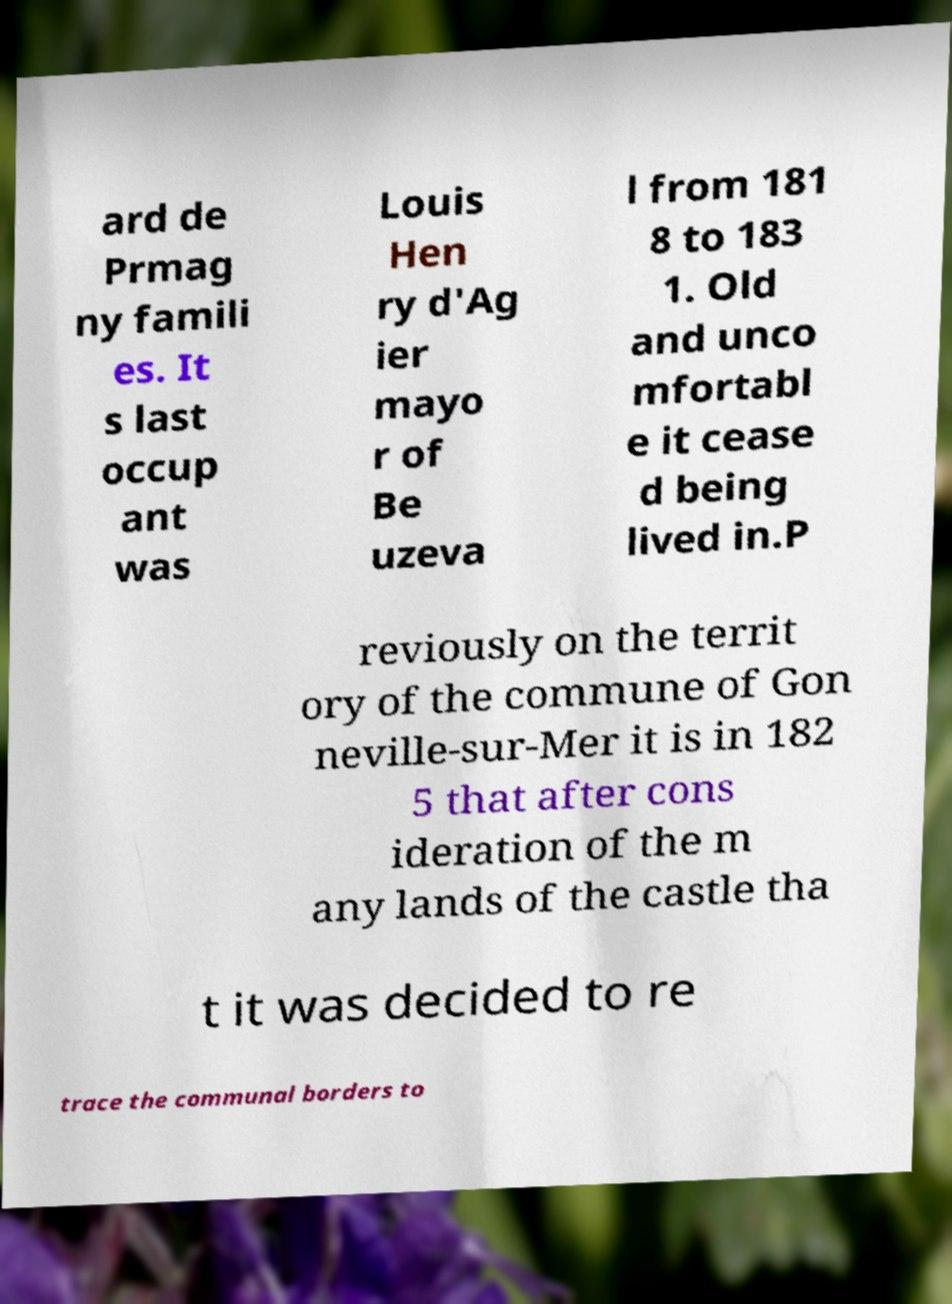Could you extract and type out the text from this image? ard de Prmag ny famili es. It s last occup ant was Louis Hen ry d'Ag ier mayo r of Be uzeva l from 181 8 to 183 1. Old and unco mfortabl e it cease d being lived in.P reviously on the territ ory of the commune of Gon neville-sur-Mer it is in 182 5 that after cons ideration of the m any lands of the castle tha t it was decided to re trace the communal borders to 